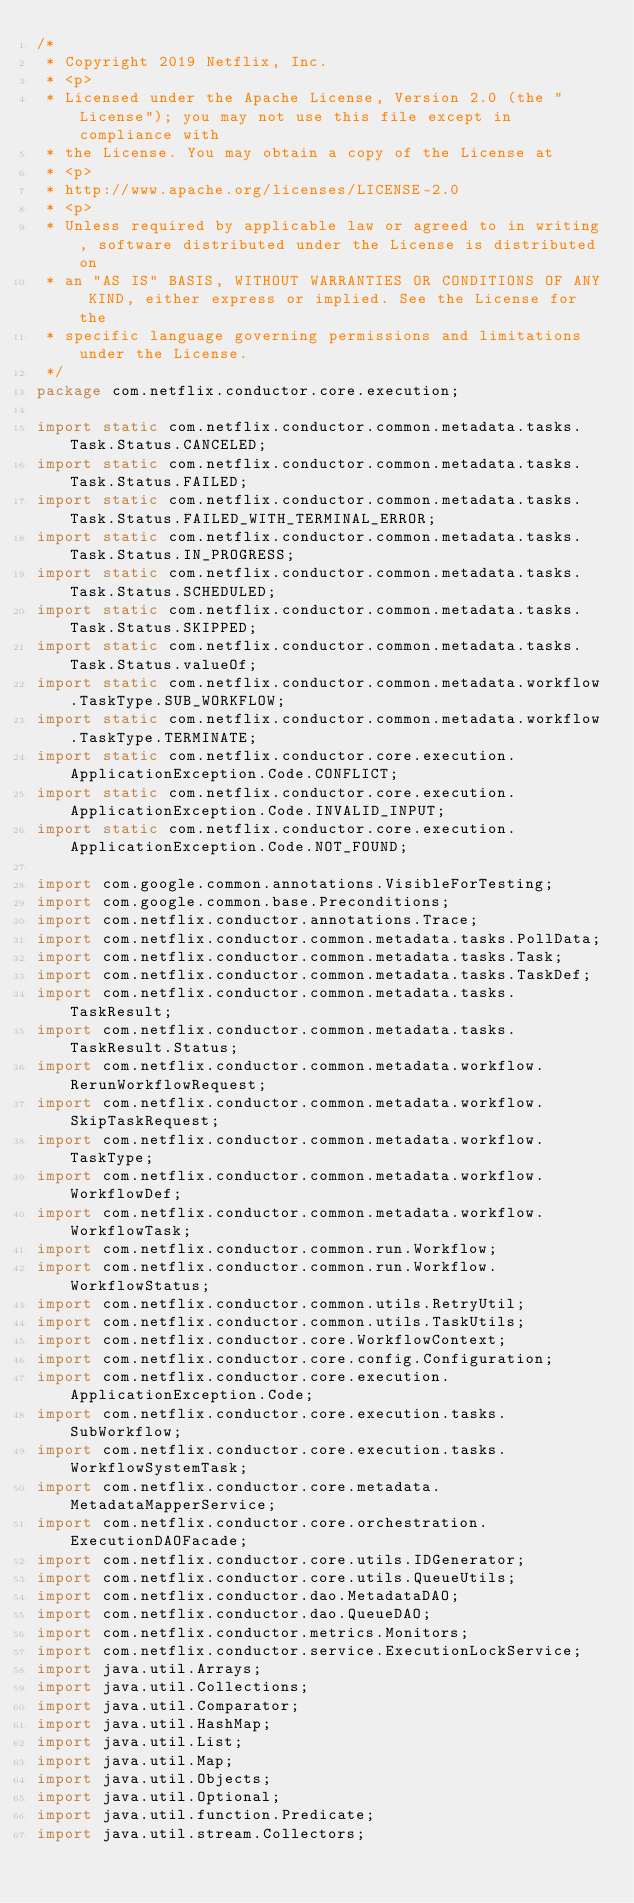<code> <loc_0><loc_0><loc_500><loc_500><_Java_>/*
 * Copyright 2019 Netflix, Inc.
 * <p>
 * Licensed under the Apache License, Version 2.0 (the "License"); you may not use this file except in compliance with
 * the License. You may obtain a copy of the License at
 * <p>
 * http://www.apache.org/licenses/LICENSE-2.0
 * <p>
 * Unless required by applicable law or agreed to in writing, software distributed under the License is distributed on
 * an "AS IS" BASIS, WITHOUT WARRANTIES OR CONDITIONS OF ANY KIND, either express or implied. See the License for the
 * specific language governing permissions and limitations under the License.
 */
package com.netflix.conductor.core.execution;

import static com.netflix.conductor.common.metadata.tasks.Task.Status.CANCELED;
import static com.netflix.conductor.common.metadata.tasks.Task.Status.FAILED;
import static com.netflix.conductor.common.metadata.tasks.Task.Status.FAILED_WITH_TERMINAL_ERROR;
import static com.netflix.conductor.common.metadata.tasks.Task.Status.IN_PROGRESS;
import static com.netflix.conductor.common.metadata.tasks.Task.Status.SCHEDULED;
import static com.netflix.conductor.common.metadata.tasks.Task.Status.SKIPPED;
import static com.netflix.conductor.common.metadata.tasks.Task.Status.valueOf;
import static com.netflix.conductor.common.metadata.workflow.TaskType.SUB_WORKFLOW;
import static com.netflix.conductor.common.metadata.workflow.TaskType.TERMINATE;
import static com.netflix.conductor.core.execution.ApplicationException.Code.CONFLICT;
import static com.netflix.conductor.core.execution.ApplicationException.Code.INVALID_INPUT;
import static com.netflix.conductor.core.execution.ApplicationException.Code.NOT_FOUND;

import com.google.common.annotations.VisibleForTesting;
import com.google.common.base.Preconditions;
import com.netflix.conductor.annotations.Trace;
import com.netflix.conductor.common.metadata.tasks.PollData;
import com.netflix.conductor.common.metadata.tasks.Task;
import com.netflix.conductor.common.metadata.tasks.TaskDef;
import com.netflix.conductor.common.metadata.tasks.TaskResult;
import com.netflix.conductor.common.metadata.tasks.TaskResult.Status;
import com.netflix.conductor.common.metadata.workflow.RerunWorkflowRequest;
import com.netflix.conductor.common.metadata.workflow.SkipTaskRequest;
import com.netflix.conductor.common.metadata.workflow.TaskType;
import com.netflix.conductor.common.metadata.workflow.WorkflowDef;
import com.netflix.conductor.common.metadata.workflow.WorkflowTask;
import com.netflix.conductor.common.run.Workflow;
import com.netflix.conductor.common.run.Workflow.WorkflowStatus;
import com.netflix.conductor.common.utils.RetryUtil;
import com.netflix.conductor.common.utils.TaskUtils;
import com.netflix.conductor.core.WorkflowContext;
import com.netflix.conductor.core.config.Configuration;
import com.netflix.conductor.core.execution.ApplicationException.Code;
import com.netflix.conductor.core.execution.tasks.SubWorkflow;
import com.netflix.conductor.core.execution.tasks.WorkflowSystemTask;
import com.netflix.conductor.core.metadata.MetadataMapperService;
import com.netflix.conductor.core.orchestration.ExecutionDAOFacade;
import com.netflix.conductor.core.utils.IDGenerator;
import com.netflix.conductor.core.utils.QueueUtils;
import com.netflix.conductor.dao.MetadataDAO;
import com.netflix.conductor.dao.QueueDAO;
import com.netflix.conductor.metrics.Monitors;
import com.netflix.conductor.service.ExecutionLockService;
import java.util.Arrays;
import java.util.Collections;
import java.util.Comparator;
import java.util.HashMap;
import java.util.List;
import java.util.Map;
import java.util.Objects;
import java.util.Optional;
import java.util.function.Predicate;
import java.util.stream.Collectors;</code> 